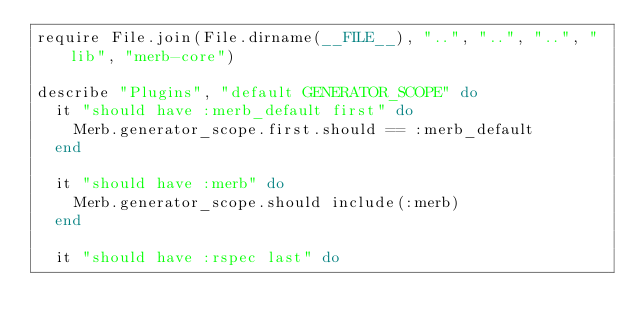<code> <loc_0><loc_0><loc_500><loc_500><_Ruby_>require File.join(File.dirname(__FILE__), "..", "..", "..", "lib", "merb-core")

describe "Plugins", "default GENERATOR_SCOPE" do
  it "should have :merb_default first" do
    Merb.generator_scope.first.should == :merb_default
  end

  it "should have :merb" do
    Merb.generator_scope.should include(:merb)
  end

  it "should have :rspec last" do</code> 